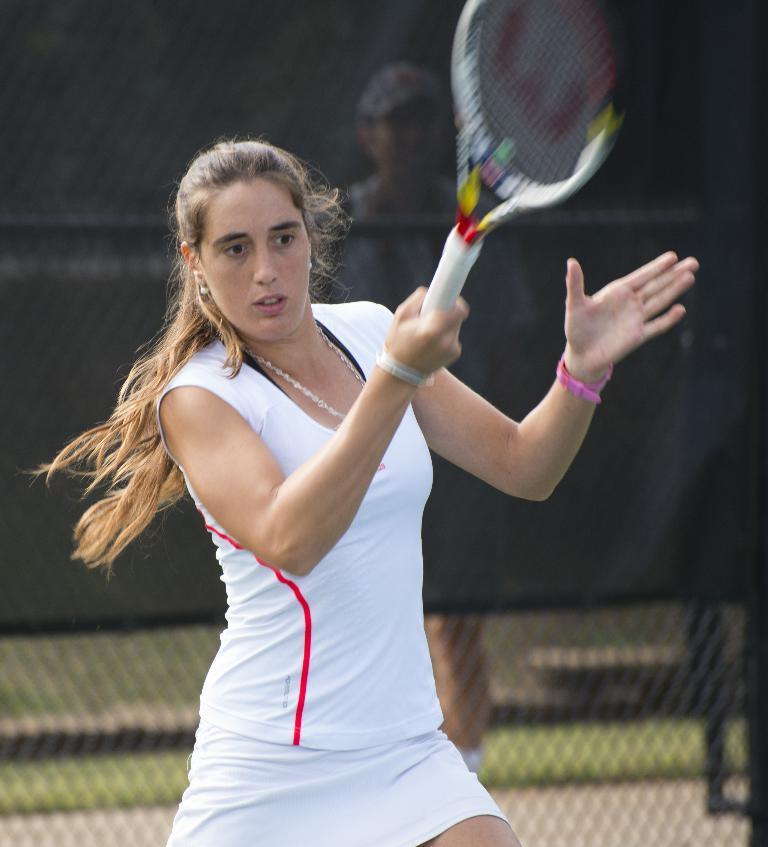How would you summarize this image in a sentence or two? There is a woman in the image who is holding tennis racket. We can also see a woman wearing watch which is in pink color, there is a man who is standing behind net fence. On the bottom we can see a grass which is in green color. 